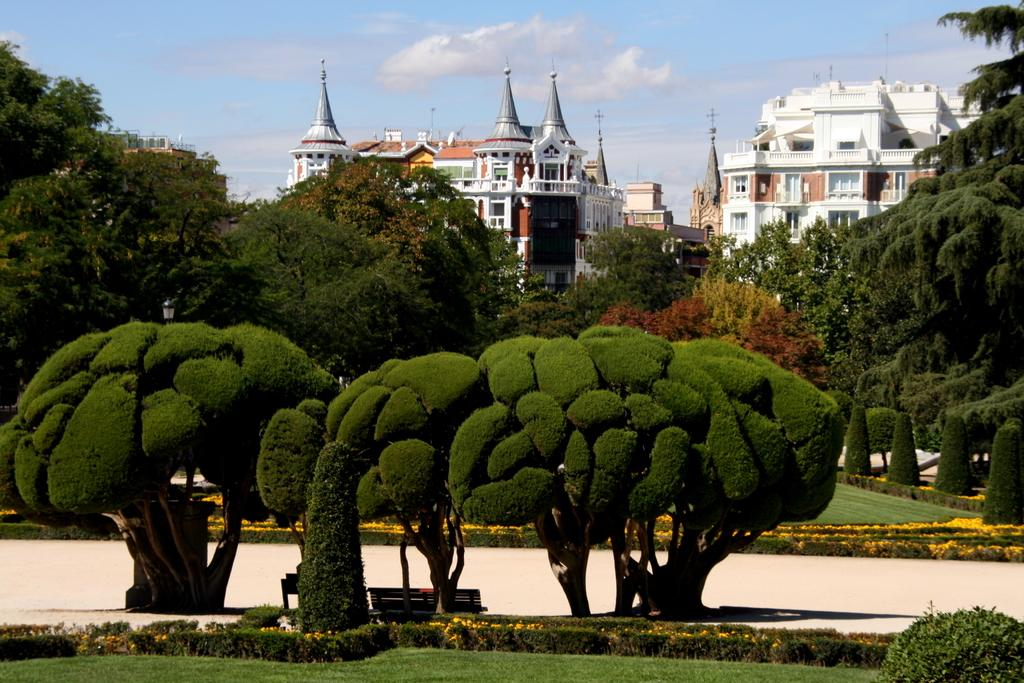What type of vegetation can be seen in the image? There are trees, bushes, and hedges in the image. What type of structures are present in the image? There are buildings and towers in the image. What type of seating is available in the image? There are benches in the image. What is visible at the bottom of the image? There is a road and ground at the bottom of the image. What is visible in the sky at the top of the image? There are clouds in the sky at the top of the image. Is there any blood visible on the benches in the image? No, there is no blood visible on the benches in the image. What grade is the school building in the image? There is no indication of a school building or any grade in the image. 